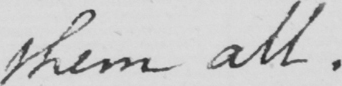Transcribe the text shown in this historical manuscript line. them all. 